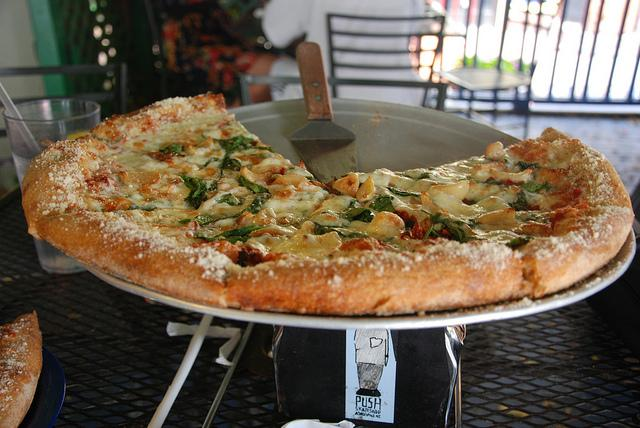What ingredients are on the pizza?

Choices:
A) spinach
B) pepperoni
C) pineapple
D) bacon spinach 